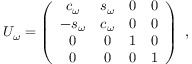Convert formula to latex. <formula><loc_0><loc_0><loc_500><loc_500>U _ { \omega } = \left ( \begin{array} { c c c c } { { c _ { \omega } } } & { { s _ { \omega } } } & { 0 } & { 0 } \\ { { - s _ { \omega } } } & { { c _ { \omega } } } & { 0 } & { 0 } \\ { 0 } & { 0 } & { 1 } & { 0 } \\ { 0 } & { 0 } & { 0 } & { 1 } \end{array} \right ) \ ,</formula> 